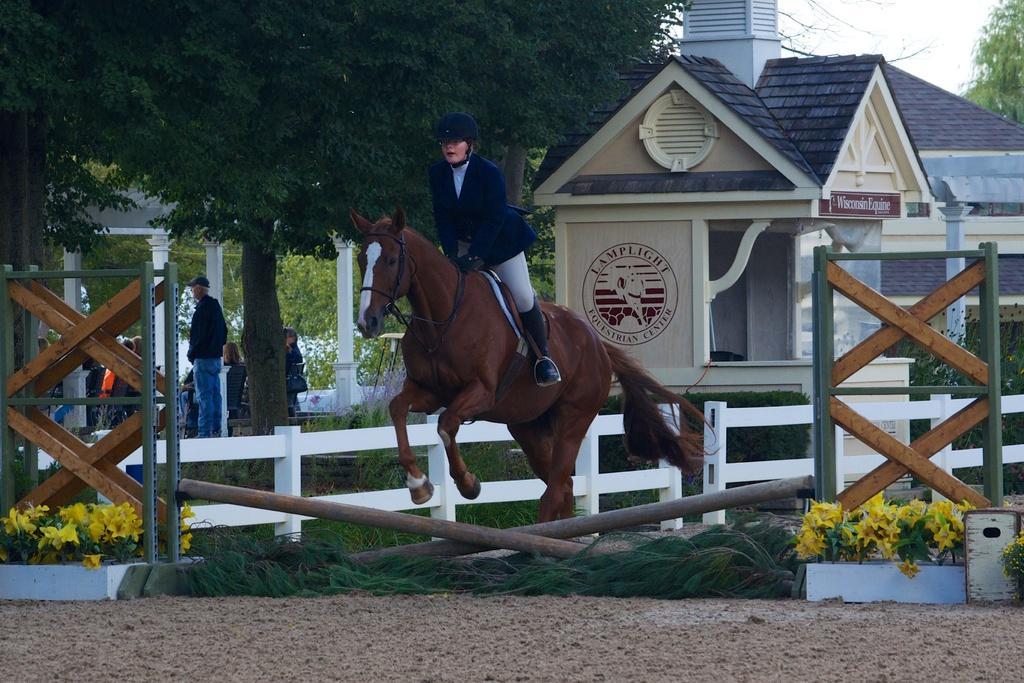Could you give a brief overview of what you see in this image? In the center of the image we can see a person is riding a horse. In the background of the image we can see the houses, trees, roof, board, text on the wall, grass, plants, flowers, railing and some people are sitting on the chairs and a man is standing. At the bottom of the image we can see the sand. In the top right corner we can see the sky. 